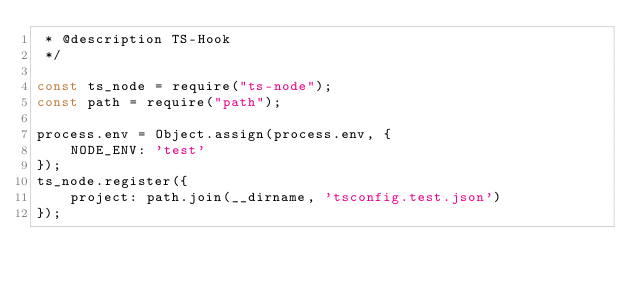Convert code to text. <code><loc_0><loc_0><loc_500><loc_500><_JavaScript_> * @description TS-Hook
 */

const ts_node = require("ts-node");
const path = require("path");

process.env = Object.assign(process.env, {
    NODE_ENV: 'test'
});
ts_node.register({
    project: path.join(__dirname, 'tsconfig.test.json')
});
</code> 